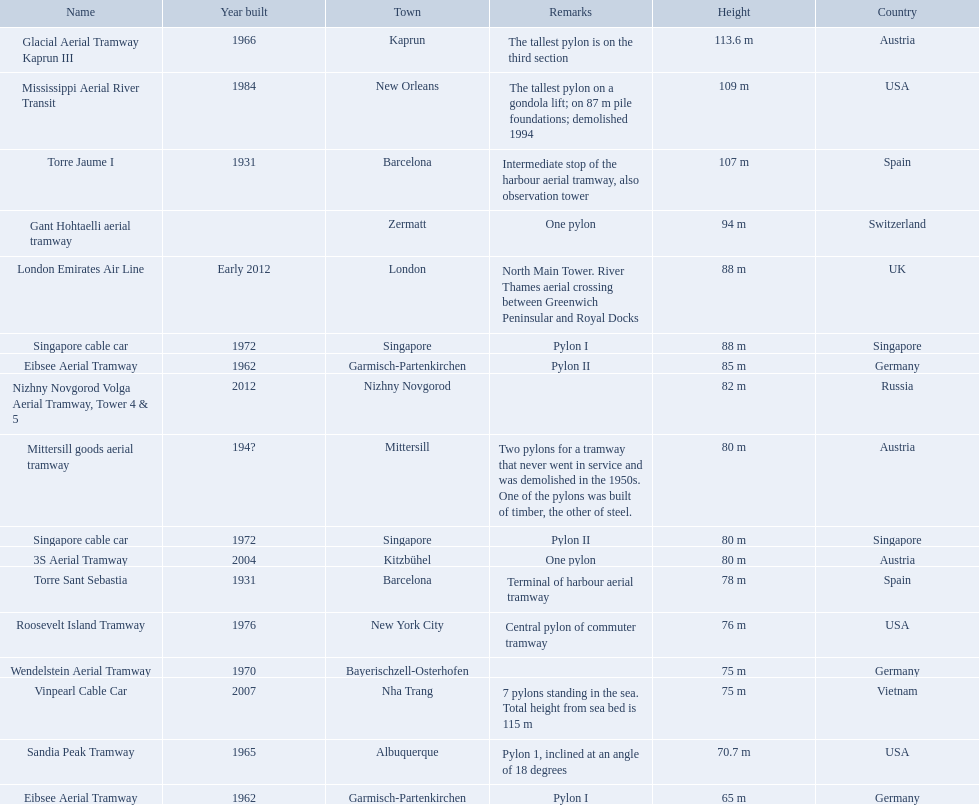Which lift has the second highest height? Mississippi Aerial River Transit. What is the value of the height? 109 m. 